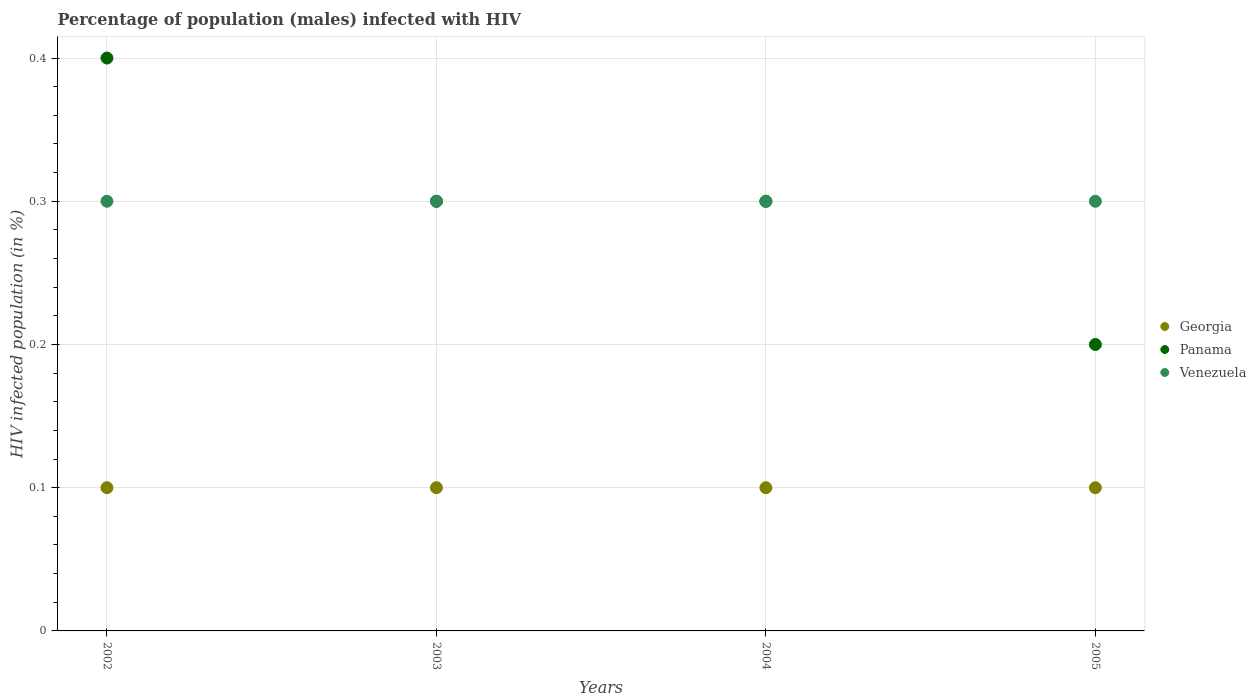Is the number of dotlines equal to the number of legend labels?
Ensure brevity in your answer.  Yes. Across all years, what is the maximum percentage of HIV infected male population in Georgia?
Ensure brevity in your answer.  0.1. Across all years, what is the minimum percentage of HIV infected male population in Panama?
Make the answer very short. 0.2. In which year was the percentage of HIV infected male population in Panama maximum?
Your answer should be compact. 2002. What is the total percentage of HIV infected male population in Georgia in the graph?
Keep it short and to the point. 0.4. What is the difference between the percentage of HIV infected male population in Georgia in 2002 and that in 2004?
Keep it short and to the point. 0. What is the difference between the percentage of HIV infected male population in Panama in 2002 and the percentage of HIV infected male population in Venezuela in 2003?
Keep it short and to the point. 0.1. What is the average percentage of HIV infected male population in Venezuela per year?
Your answer should be very brief. 0.3. In the year 2004, what is the difference between the percentage of HIV infected male population in Venezuela and percentage of HIV infected male population in Panama?
Ensure brevity in your answer.  0. Is the difference between the percentage of HIV infected male population in Venezuela in 2003 and 2005 greater than the difference between the percentage of HIV infected male population in Panama in 2003 and 2005?
Provide a short and direct response. No. Is the sum of the percentage of HIV infected male population in Venezuela in 2004 and 2005 greater than the maximum percentage of HIV infected male population in Panama across all years?
Ensure brevity in your answer.  Yes. Does the percentage of HIV infected male population in Panama monotonically increase over the years?
Keep it short and to the point. No. How many dotlines are there?
Make the answer very short. 3. How many years are there in the graph?
Your response must be concise. 4. What is the difference between two consecutive major ticks on the Y-axis?
Ensure brevity in your answer.  0.1. Are the values on the major ticks of Y-axis written in scientific E-notation?
Your answer should be compact. No. Does the graph contain any zero values?
Offer a terse response. No. Where does the legend appear in the graph?
Provide a succinct answer. Center right. How many legend labels are there?
Provide a succinct answer. 3. What is the title of the graph?
Ensure brevity in your answer.  Percentage of population (males) infected with HIV. Does "Norway" appear as one of the legend labels in the graph?
Make the answer very short. No. What is the label or title of the Y-axis?
Provide a succinct answer. HIV infected population (in %). What is the HIV infected population (in %) of Venezuela in 2004?
Your answer should be compact. 0.3. What is the HIV infected population (in %) in Venezuela in 2005?
Provide a succinct answer. 0.3. Across all years, what is the maximum HIV infected population (in %) in Georgia?
Offer a very short reply. 0.1. Across all years, what is the maximum HIV infected population (in %) in Panama?
Your answer should be compact. 0.4. Across all years, what is the minimum HIV infected population (in %) in Georgia?
Make the answer very short. 0.1. Across all years, what is the minimum HIV infected population (in %) of Panama?
Keep it short and to the point. 0.2. What is the total HIV infected population (in %) of Venezuela in the graph?
Offer a very short reply. 1.2. What is the difference between the HIV infected population (in %) in Georgia in 2002 and that in 2003?
Provide a succinct answer. 0. What is the difference between the HIV infected population (in %) in Georgia in 2002 and that in 2004?
Offer a very short reply. 0. What is the difference between the HIV infected population (in %) in Panama in 2002 and that in 2004?
Provide a succinct answer. 0.1. What is the difference between the HIV infected population (in %) of Georgia in 2002 and that in 2005?
Ensure brevity in your answer.  0. What is the difference between the HIV infected population (in %) in Panama in 2002 and that in 2005?
Make the answer very short. 0.2. What is the difference between the HIV infected population (in %) in Venezuela in 2002 and that in 2005?
Your answer should be very brief. 0. What is the difference between the HIV infected population (in %) in Georgia in 2003 and that in 2004?
Make the answer very short. 0. What is the difference between the HIV infected population (in %) of Panama in 2003 and that in 2005?
Keep it short and to the point. 0.1. What is the difference between the HIV infected population (in %) of Venezuela in 2003 and that in 2005?
Your answer should be very brief. 0. What is the difference between the HIV infected population (in %) in Georgia in 2002 and the HIV infected population (in %) in Venezuela in 2003?
Make the answer very short. -0.2. What is the difference between the HIV infected population (in %) in Georgia in 2002 and the HIV infected population (in %) in Panama in 2004?
Keep it short and to the point. -0.2. What is the difference between the HIV infected population (in %) in Georgia in 2002 and the HIV infected population (in %) in Venezuela in 2004?
Ensure brevity in your answer.  -0.2. What is the difference between the HIV infected population (in %) of Georgia in 2002 and the HIV infected population (in %) of Panama in 2005?
Your response must be concise. -0.1. What is the difference between the HIV infected population (in %) of Georgia in 2003 and the HIV infected population (in %) of Panama in 2004?
Ensure brevity in your answer.  -0.2. What is the difference between the HIV infected population (in %) of Panama in 2003 and the HIV infected population (in %) of Venezuela in 2004?
Keep it short and to the point. 0. What is the difference between the HIV infected population (in %) of Georgia in 2003 and the HIV infected population (in %) of Panama in 2005?
Offer a very short reply. -0.1. What is the difference between the HIV infected population (in %) of Georgia in 2003 and the HIV infected population (in %) of Venezuela in 2005?
Offer a very short reply. -0.2. What is the difference between the HIV infected population (in %) in Georgia in 2004 and the HIV infected population (in %) in Panama in 2005?
Give a very brief answer. -0.1. In the year 2002, what is the difference between the HIV infected population (in %) of Georgia and HIV infected population (in %) of Panama?
Provide a short and direct response. -0.3. In the year 2003, what is the difference between the HIV infected population (in %) in Georgia and HIV infected population (in %) in Panama?
Your answer should be compact. -0.2. In the year 2005, what is the difference between the HIV infected population (in %) of Georgia and HIV infected population (in %) of Panama?
Your answer should be very brief. -0.1. What is the ratio of the HIV infected population (in %) in Panama in 2002 to that in 2003?
Provide a short and direct response. 1.33. What is the ratio of the HIV infected population (in %) in Georgia in 2002 to that in 2004?
Your answer should be compact. 1. What is the ratio of the HIV infected population (in %) of Panama in 2002 to that in 2004?
Offer a terse response. 1.33. What is the ratio of the HIV infected population (in %) in Venezuela in 2002 to that in 2004?
Your answer should be very brief. 1. What is the ratio of the HIV infected population (in %) of Georgia in 2002 to that in 2005?
Keep it short and to the point. 1. What is the ratio of the HIV infected population (in %) in Georgia in 2003 to that in 2004?
Ensure brevity in your answer.  1. What is the ratio of the HIV infected population (in %) in Venezuela in 2003 to that in 2004?
Provide a short and direct response. 1. What is the ratio of the HIV infected population (in %) in Panama in 2003 to that in 2005?
Ensure brevity in your answer.  1.5. What is the ratio of the HIV infected population (in %) in Venezuela in 2004 to that in 2005?
Keep it short and to the point. 1. What is the difference between the highest and the second highest HIV infected population (in %) of Georgia?
Your response must be concise. 0. What is the difference between the highest and the lowest HIV infected population (in %) in Georgia?
Make the answer very short. 0. What is the difference between the highest and the lowest HIV infected population (in %) in Venezuela?
Provide a short and direct response. 0. 